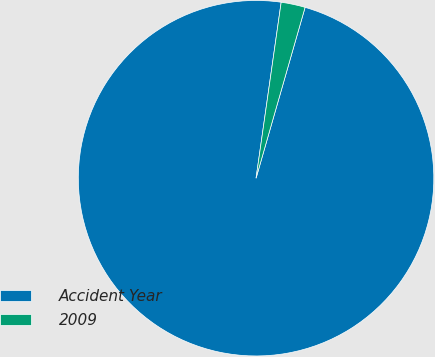Convert chart. <chart><loc_0><loc_0><loc_500><loc_500><pie_chart><fcel>Accident Year<fcel>2009<nl><fcel>97.81%<fcel>2.19%<nl></chart> 